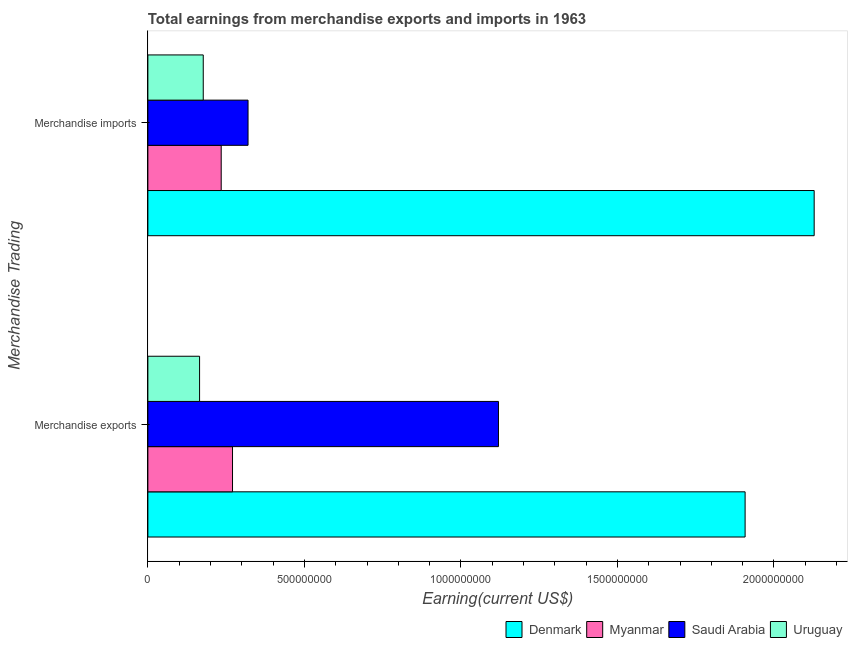How many groups of bars are there?
Ensure brevity in your answer.  2. Are the number of bars per tick equal to the number of legend labels?
Keep it short and to the point. Yes. Are the number of bars on each tick of the Y-axis equal?
Make the answer very short. Yes. How many bars are there on the 1st tick from the top?
Your answer should be very brief. 4. What is the label of the 2nd group of bars from the top?
Your answer should be very brief. Merchandise exports. What is the earnings from merchandise exports in Myanmar?
Make the answer very short. 2.70e+08. Across all countries, what is the maximum earnings from merchandise imports?
Offer a terse response. 2.13e+09. Across all countries, what is the minimum earnings from merchandise exports?
Your answer should be compact. 1.65e+08. In which country was the earnings from merchandise exports minimum?
Ensure brevity in your answer.  Uruguay. What is the total earnings from merchandise exports in the graph?
Ensure brevity in your answer.  3.46e+09. What is the difference between the earnings from merchandise imports in Uruguay and that in Myanmar?
Offer a terse response. -5.74e+07. What is the difference between the earnings from merchandise imports in Myanmar and the earnings from merchandise exports in Denmark?
Offer a terse response. -1.67e+09. What is the average earnings from merchandise imports per country?
Offer a very short reply. 7.15e+08. What is the difference between the earnings from merchandise imports and earnings from merchandise exports in Uruguay?
Offer a very short reply. 1.17e+07. In how many countries, is the earnings from merchandise imports greater than 2000000000 US$?
Provide a succinct answer. 1. What is the ratio of the earnings from merchandise exports in Denmark to that in Myanmar?
Ensure brevity in your answer.  7.06. In how many countries, is the earnings from merchandise imports greater than the average earnings from merchandise imports taken over all countries?
Your answer should be compact. 1. What does the 2nd bar from the top in Merchandise imports represents?
Provide a succinct answer. Saudi Arabia. What does the 3rd bar from the bottom in Merchandise exports represents?
Give a very brief answer. Saudi Arabia. How many countries are there in the graph?
Give a very brief answer. 4. Are the values on the major ticks of X-axis written in scientific E-notation?
Your response must be concise. No. Does the graph contain any zero values?
Your response must be concise. No. How many legend labels are there?
Offer a very short reply. 4. What is the title of the graph?
Ensure brevity in your answer.  Total earnings from merchandise exports and imports in 1963. Does "Afghanistan" appear as one of the legend labels in the graph?
Make the answer very short. No. What is the label or title of the X-axis?
Provide a short and direct response. Earning(current US$). What is the label or title of the Y-axis?
Provide a succinct answer. Merchandise Trading. What is the Earning(current US$) in Denmark in Merchandise exports?
Your answer should be very brief. 1.91e+09. What is the Earning(current US$) of Myanmar in Merchandise exports?
Provide a succinct answer. 2.70e+08. What is the Earning(current US$) in Saudi Arabia in Merchandise exports?
Give a very brief answer. 1.12e+09. What is the Earning(current US$) of Uruguay in Merchandise exports?
Make the answer very short. 1.65e+08. What is the Earning(current US$) in Denmark in Merchandise imports?
Your answer should be compact. 2.13e+09. What is the Earning(current US$) in Myanmar in Merchandise imports?
Make the answer very short. 2.34e+08. What is the Earning(current US$) in Saudi Arabia in Merchandise imports?
Your answer should be very brief. 3.20e+08. What is the Earning(current US$) in Uruguay in Merchandise imports?
Provide a succinct answer. 1.77e+08. Across all Merchandise Trading, what is the maximum Earning(current US$) in Denmark?
Ensure brevity in your answer.  2.13e+09. Across all Merchandise Trading, what is the maximum Earning(current US$) in Myanmar?
Provide a short and direct response. 2.70e+08. Across all Merchandise Trading, what is the maximum Earning(current US$) of Saudi Arabia?
Offer a terse response. 1.12e+09. Across all Merchandise Trading, what is the maximum Earning(current US$) in Uruguay?
Offer a terse response. 1.77e+08. Across all Merchandise Trading, what is the minimum Earning(current US$) in Denmark?
Your response must be concise. 1.91e+09. Across all Merchandise Trading, what is the minimum Earning(current US$) in Myanmar?
Provide a short and direct response. 2.34e+08. Across all Merchandise Trading, what is the minimum Earning(current US$) of Saudi Arabia?
Ensure brevity in your answer.  3.20e+08. Across all Merchandise Trading, what is the minimum Earning(current US$) in Uruguay?
Your answer should be compact. 1.65e+08. What is the total Earning(current US$) of Denmark in the graph?
Offer a very short reply. 4.04e+09. What is the total Earning(current US$) of Myanmar in the graph?
Ensure brevity in your answer.  5.05e+08. What is the total Earning(current US$) in Saudi Arabia in the graph?
Offer a terse response. 1.44e+09. What is the total Earning(current US$) of Uruguay in the graph?
Ensure brevity in your answer.  3.42e+08. What is the difference between the Earning(current US$) in Denmark in Merchandise exports and that in Merchandise imports?
Provide a succinct answer. -2.21e+08. What is the difference between the Earning(current US$) in Myanmar in Merchandise exports and that in Merchandise imports?
Make the answer very short. 3.61e+07. What is the difference between the Earning(current US$) in Saudi Arabia in Merchandise exports and that in Merchandise imports?
Make the answer very short. 8.00e+08. What is the difference between the Earning(current US$) in Uruguay in Merchandise exports and that in Merchandise imports?
Keep it short and to the point. -1.17e+07. What is the difference between the Earning(current US$) of Denmark in Merchandise exports and the Earning(current US$) of Myanmar in Merchandise imports?
Provide a succinct answer. 1.67e+09. What is the difference between the Earning(current US$) in Denmark in Merchandise exports and the Earning(current US$) in Saudi Arabia in Merchandise imports?
Keep it short and to the point. 1.59e+09. What is the difference between the Earning(current US$) in Denmark in Merchandise exports and the Earning(current US$) in Uruguay in Merchandise imports?
Keep it short and to the point. 1.73e+09. What is the difference between the Earning(current US$) in Myanmar in Merchandise exports and the Earning(current US$) in Saudi Arabia in Merchandise imports?
Offer a very short reply. -4.96e+07. What is the difference between the Earning(current US$) of Myanmar in Merchandise exports and the Earning(current US$) of Uruguay in Merchandise imports?
Provide a succinct answer. 9.35e+07. What is the difference between the Earning(current US$) in Saudi Arabia in Merchandise exports and the Earning(current US$) in Uruguay in Merchandise imports?
Make the answer very short. 9.43e+08. What is the average Earning(current US$) of Denmark per Merchandise Trading?
Your response must be concise. 2.02e+09. What is the average Earning(current US$) in Myanmar per Merchandise Trading?
Keep it short and to the point. 2.52e+08. What is the average Earning(current US$) of Saudi Arabia per Merchandise Trading?
Ensure brevity in your answer.  7.20e+08. What is the average Earning(current US$) in Uruguay per Merchandise Trading?
Your answer should be very brief. 1.71e+08. What is the difference between the Earning(current US$) of Denmark and Earning(current US$) of Myanmar in Merchandise exports?
Provide a succinct answer. 1.64e+09. What is the difference between the Earning(current US$) in Denmark and Earning(current US$) in Saudi Arabia in Merchandise exports?
Provide a short and direct response. 7.88e+08. What is the difference between the Earning(current US$) of Denmark and Earning(current US$) of Uruguay in Merchandise exports?
Make the answer very short. 1.74e+09. What is the difference between the Earning(current US$) in Myanmar and Earning(current US$) in Saudi Arabia in Merchandise exports?
Make the answer very short. -8.50e+08. What is the difference between the Earning(current US$) of Myanmar and Earning(current US$) of Uruguay in Merchandise exports?
Keep it short and to the point. 1.05e+08. What is the difference between the Earning(current US$) in Saudi Arabia and Earning(current US$) in Uruguay in Merchandise exports?
Offer a terse response. 9.55e+08. What is the difference between the Earning(current US$) of Denmark and Earning(current US$) of Myanmar in Merchandise imports?
Your answer should be compact. 1.89e+09. What is the difference between the Earning(current US$) in Denmark and Earning(current US$) in Saudi Arabia in Merchandise imports?
Provide a succinct answer. 1.81e+09. What is the difference between the Earning(current US$) in Denmark and Earning(current US$) in Uruguay in Merchandise imports?
Your response must be concise. 1.95e+09. What is the difference between the Earning(current US$) in Myanmar and Earning(current US$) in Saudi Arabia in Merchandise imports?
Give a very brief answer. -8.57e+07. What is the difference between the Earning(current US$) in Myanmar and Earning(current US$) in Uruguay in Merchandise imports?
Offer a very short reply. 5.74e+07. What is the difference between the Earning(current US$) of Saudi Arabia and Earning(current US$) of Uruguay in Merchandise imports?
Your answer should be compact. 1.43e+08. What is the ratio of the Earning(current US$) in Denmark in Merchandise exports to that in Merchandise imports?
Offer a very short reply. 0.9. What is the ratio of the Earning(current US$) in Myanmar in Merchandise exports to that in Merchandise imports?
Provide a succinct answer. 1.15. What is the ratio of the Earning(current US$) in Saudi Arabia in Merchandise exports to that in Merchandise imports?
Your answer should be very brief. 3.5. What is the ratio of the Earning(current US$) in Uruguay in Merchandise exports to that in Merchandise imports?
Your answer should be compact. 0.93. What is the difference between the highest and the second highest Earning(current US$) in Denmark?
Ensure brevity in your answer.  2.21e+08. What is the difference between the highest and the second highest Earning(current US$) in Myanmar?
Offer a terse response. 3.61e+07. What is the difference between the highest and the second highest Earning(current US$) in Saudi Arabia?
Offer a very short reply. 8.00e+08. What is the difference between the highest and the second highest Earning(current US$) of Uruguay?
Offer a terse response. 1.17e+07. What is the difference between the highest and the lowest Earning(current US$) in Denmark?
Offer a terse response. 2.21e+08. What is the difference between the highest and the lowest Earning(current US$) of Myanmar?
Provide a short and direct response. 3.61e+07. What is the difference between the highest and the lowest Earning(current US$) in Saudi Arabia?
Ensure brevity in your answer.  8.00e+08. What is the difference between the highest and the lowest Earning(current US$) of Uruguay?
Your answer should be very brief. 1.17e+07. 